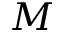Convert formula to latex. <formula><loc_0><loc_0><loc_500><loc_500>M</formula> 